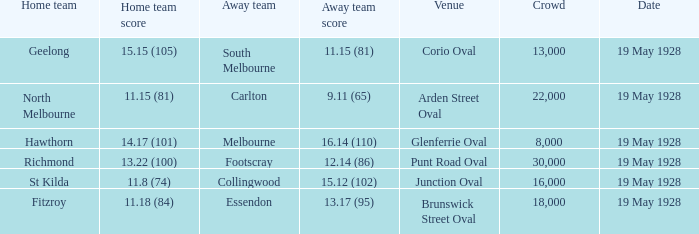What was the listed crowd at junction oval? 16000.0. 